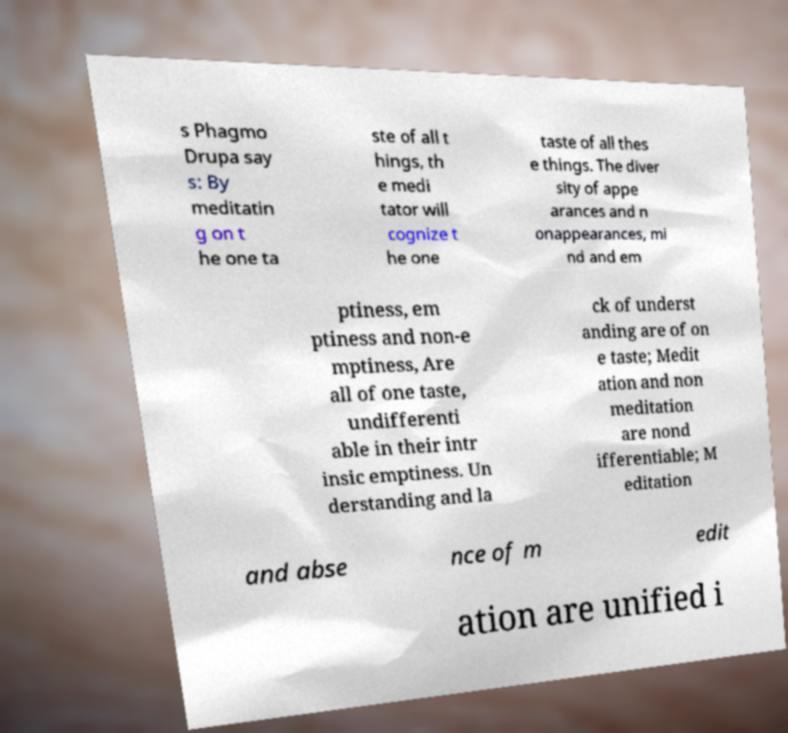Could you assist in decoding the text presented in this image and type it out clearly? s Phagmo Drupa say s: By meditatin g on t he one ta ste of all t hings, th e medi tator will cognize t he one taste of all thes e things. The diver sity of appe arances and n onappearances, mi nd and em ptiness, em ptiness and non-e mptiness, Are all of one taste, undifferenti able in their intr insic emptiness. Un derstanding and la ck of underst anding are of on e taste; Medit ation and non meditation are nond ifferentiable; M editation and abse nce of m edit ation are unified i 